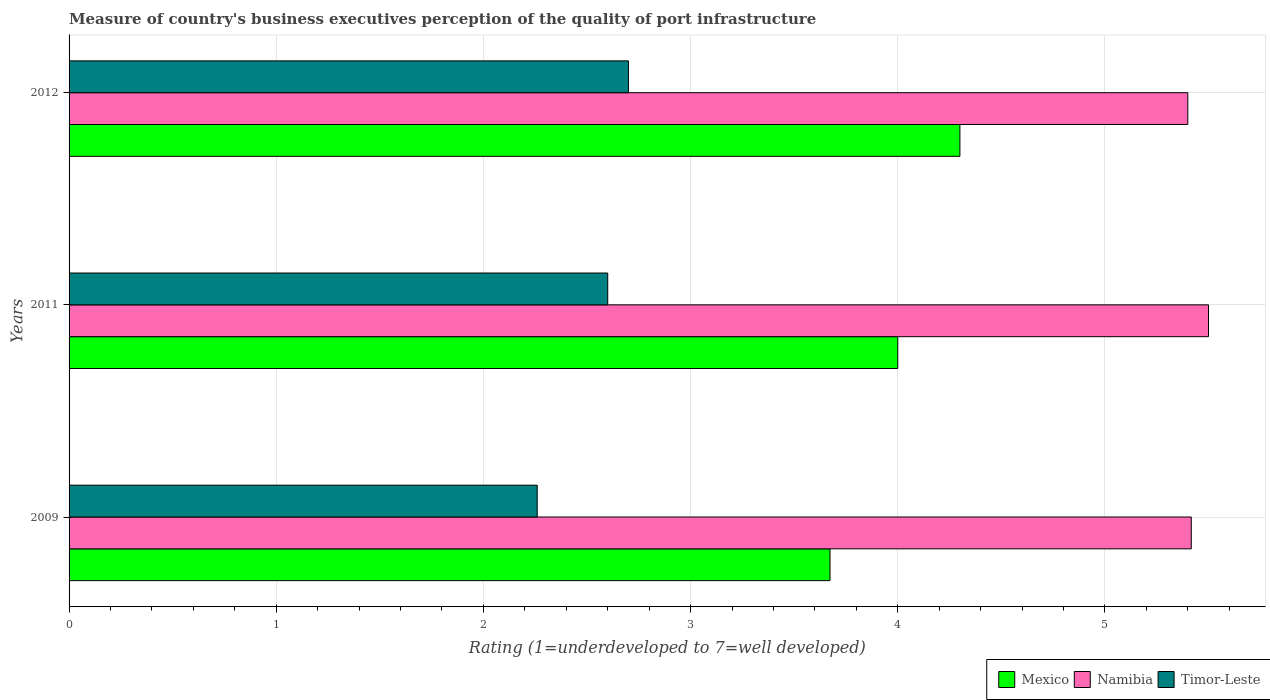How many different coloured bars are there?
Offer a terse response. 3. Are the number of bars per tick equal to the number of legend labels?
Provide a short and direct response. Yes. Are the number of bars on each tick of the Y-axis equal?
Make the answer very short. Yes. How many bars are there on the 2nd tick from the bottom?
Provide a short and direct response. 3. What is the ratings of the quality of port infrastructure in Namibia in 2009?
Provide a short and direct response. 5.42. Across all years, what is the minimum ratings of the quality of port infrastructure in Mexico?
Offer a very short reply. 3.67. What is the total ratings of the quality of port infrastructure in Mexico in the graph?
Offer a terse response. 11.97. What is the difference between the ratings of the quality of port infrastructure in Timor-Leste in 2011 and that in 2012?
Offer a terse response. -0.1. What is the difference between the ratings of the quality of port infrastructure in Namibia in 2009 and the ratings of the quality of port infrastructure in Mexico in 2012?
Offer a very short reply. 1.12. What is the average ratings of the quality of port infrastructure in Namibia per year?
Provide a succinct answer. 5.44. What is the ratio of the ratings of the quality of port infrastructure in Mexico in 2009 to that in 2012?
Keep it short and to the point. 0.85. What is the difference between the highest and the second highest ratings of the quality of port infrastructure in Timor-Leste?
Provide a short and direct response. 0.1. What is the difference between the highest and the lowest ratings of the quality of port infrastructure in Mexico?
Offer a terse response. 0.63. In how many years, is the ratings of the quality of port infrastructure in Namibia greater than the average ratings of the quality of port infrastructure in Namibia taken over all years?
Offer a terse response. 1. What does the 1st bar from the top in 2011 represents?
Offer a very short reply. Timor-Leste. What does the 2nd bar from the bottom in 2009 represents?
Your response must be concise. Namibia. Is it the case that in every year, the sum of the ratings of the quality of port infrastructure in Namibia and ratings of the quality of port infrastructure in Mexico is greater than the ratings of the quality of port infrastructure in Timor-Leste?
Your response must be concise. Yes. Are all the bars in the graph horizontal?
Make the answer very short. Yes. How many years are there in the graph?
Ensure brevity in your answer.  3. Are the values on the major ticks of X-axis written in scientific E-notation?
Keep it short and to the point. No. Does the graph contain any zero values?
Keep it short and to the point. No. Where does the legend appear in the graph?
Make the answer very short. Bottom right. How many legend labels are there?
Your answer should be very brief. 3. How are the legend labels stacked?
Give a very brief answer. Horizontal. What is the title of the graph?
Offer a terse response. Measure of country's business executives perception of the quality of port infrastructure. What is the label or title of the X-axis?
Your answer should be compact. Rating (1=underdeveloped to 7=well developed). What is the label or title of the Y-axis?
Your response must be concise. Years. What is the Rating (1=underdeveloped to 7=well developed) of Mexico in 2009?
Give a very brief answer. 3.67. What is the Rating (1=underdeveloped to 7=well developed) of Namibia in 2009?
Your answer should be very brief. 5.42. What is the Rating (1=underdeveloped to 7=well developed) in Timor-Leste in 2009?
Offer a terse response. 2.26. What is the Rating (1=underdeveloped to 7=well developed) in Timor-Leste in 2011?
Provide a succinct answer. 2.6. Across all years, what is the maximum Rating (1=underdeveloped to 7=well developed) in Mexico?
Your answer should be very brief. 4.3. Across all years, what is the maximum Rating (1=underdeveloped to 7=well developed) in Namibia?
Give a very brief answer. 5.5. Across all years, what is the maximum Rating (1=underdeveloped to 7=well developed) in Timor-Leste?
Provide a succinct answer. 2.7. Across all years, what is the minimum Rating (1=underdeveloped to 7=well developed) of Mexico?
Provide a succinct answer. 3.67. Across all years, what is the minimum Rating (1=underdeveloped to 7=well developed) in Timor-Leste?
Keep it short and to the point. 2.26. What is the total Rating (1=underdeveloped to 7=well developed) of Mexico in the graph?
Your response must be concise. 11.97. What is the total Rating (1=underdeveloped to 7=well developed) in Namibia in the graph?
Your answer should be compact. 16.32. What is the total Rating (1=underdeveloped to 7=well developed) in Timor-Leste in the graph?
Ensure brevity in your answer.  7.56. What is the difference between the Rating (1=underdeveloped to 7=well developed) of Mexico in 2009 and that in 2011?
Provide a succinct answer. -0.33. What is the difference between the Rating (1=underdeveloped to 7=well developed) of Namibia in 2009 and that in 2011?
Your answer should be compact. -0.08. What is the difference between the Rating (1=underdeveloped to 7=well developed) of Timor-Leste in 2009 and that in 2011?
Provide a succinct answer. -0.34. What is the difference between the Rating (1=underdeveloped to 7=well developed) of Mexico in 2009 and that in 2012?
Keep it short and to the point. -0.63. What is the difference between the Rating (1=underdeveloped to 7=well developed) in Namibia in 2009 and that in 2012?
Your answer should be very brief. 0.02. What is the difference between the Rating (1=underdeveloped to 7=well developed) of Timor-Leste in 2009 and that in 2012?
Your answer should be very brief. -0.44. What is the difference between the Rating (1=underdeveloped to 7=well developed) of Mexico in 2009 and the Rating (1=underdeveloped to 7=well developed) of Namibia in 2011?
Ensure brevity in your answer.  -1.83. What is the difference between the Rating (1=underdeveloped to 7=well developed) in Mexico in 2009 and the Rating (1=underdeveloped to 7=well developed) in Timor-Leste in 2011?
Your answer should be compact. 1.07. What is the difference between the Rating (1=underdeveloped to 7=well developed) of Namibia in 2009 and the Rating (1=underdeveloped to 7=well developed) of Timor-Leste in 2011?
Your response must be concise. 2.82. What is the difference between the Rating (1=underdeveloped to 7=well developed) in Mexico in 2009 and the Rating (1=underdeveloped to 7=well developed) in Namibia in 2012?
Your answer should be compact. -1.73. What is the difference between the Rating (1=underdeveloped to 7=well developed) in Mexico in 2009 and the Rating (1=underdeveloped to 7=well developed) in Timor-Leste in 2012?
Your answer should be very brief. 0.97. What is the difference between the Rating (1=underdeveloped to 7=well developed) of Namibia in 2009 and the Rating (1=underdeveloped to 7=well developed) of Timor-Leste in 2012?
Provide a short and direct response. 2.72. What is the average Rating (1=underdeveloped to 7=well developed) in Mexico per year?
Provide a succinct answer. 3.99. What is the average Rating (1=underdeveloped to 7=well developed) in Namibia per year?
Provide a short and direct response. 5.44. What is the average Rating (1=underdeveloped to 7=well developed) in Timor-Leste per year?
Your answer should be very brief. 2.52. In the year 2009, what is the difference between the Rating (1=underdeveloped to 7=well developed) in Mexico and Rating (1=underdeveloped to 7=well developed) in Namibia?
Your answer should be very brief. -1.74. In the year 2009, what is the difference between the Rating (1=underdeveloped to 7=well developed) of Mexico and Rating (1=underdeveloped to 7=well developed) of Timor-Leste?
Make the answer very short. 1.41. In the year 2009, what is the difference between the Rating (1=underdeveloped to 7=well developed) in Namibia and Rating (1=underdeveloped to 7=well developed) in Timor-Leste?
Offer a very short reply. 3.16. In the year 2011, what is the difference between the Rating (1=underdeveloped to 7=well developed) in Mexico and Rating (1=underdeveloped to 7=well developed) in Namibia?
Offer a very short reply. -1.5. What is the ratio of the Rating (1=underdeveloped to 7=well developed) of Mexico in 2009 to that in 2011?
Make the answer very short. 0.92. What is the ratio of the Rating (1=underdeveloped to 7=well developed) in Namibia in 2009 to that in 2011?
Your response must be concise. 0.98. What is the ratio of the Rating (1=underdeveloped to 7=well developed) of Timor-Leste in 2009 to that in 2011?
Your answer should be compact. 0.87. What is the ratio of the Rating (1=underdeveloped to 7=well developed) of Mexico in 2009 to that in 2012?
Offer a very short reply. 0.85. What is the ratio of the Rating (1=underdeveloped to 7=well developed) of Timor-Leste in 2009 to that in 2012?
Your answer should be very brief. 0.84. What is the ratio of the Rating (1=underdeveloped to 7=well developed) of Mexico in 2011 to that in 2012?
Provide a short and direct response. 0.93. What is the ratio of the Rating (1=underdeveloped to 7=well developed) of Namibia in 2011 to that in 2012?
Your answer should be very brief. 1.02. What is the ratio of the Rating (1=underdeveloped to 7=well developed) in Timor-Leste in 2011 to that in 2012?
Your answer should be very brief. 0.96. What is the difference between the highest and the second highest Rating (1=underdeveloped to 7=well developed) of Namibia?
Your answer should be compact. 0.08. What is the difference between the highest and the lowest Rating (1=underdeveloped to 7=well developed) of Mexico?
Make the answer very short. 0.63. What is the difference between the highest and the lowest Rating (1=underdeveloped to 7=well developed) of Timor-Leste?
Your answer should be very brief. 0.44. 